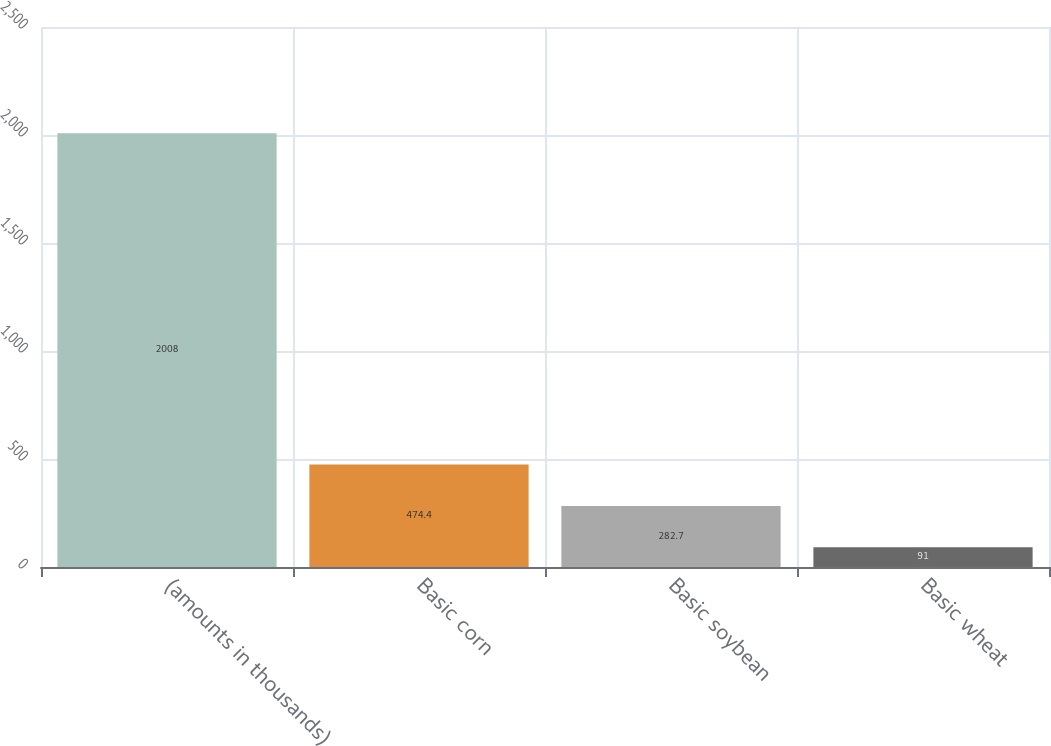Convert chart to OTSL. <chart><loc_0><loc_0><loc_500><loc_500><bar_chart><fcel>(amounts in thousands)<fcel>Basic corn<fcel>Basic soybean<fcel>Basic wheat<nl><fcel>2008<fcel>474.4<fcel>282.7<fcel>91<nl></chart> 